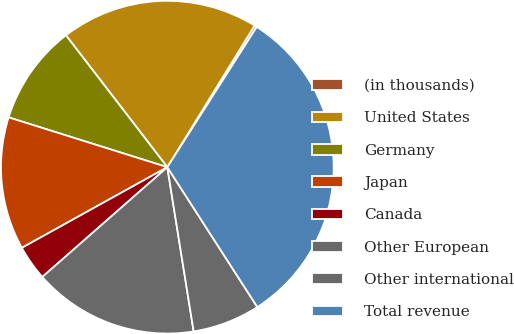<chart> <loc_0><loc_0><loc_500><loc_500><pie_chart><fcel>(in thousands)<fcel>United States<fcel>Germany<fcel>Japan<fcel>Canada<fcel>Other European<fcel>Other international<fcel>Total revenue<nl><fcel>0.24%<fcel>19.22%<fcel>9.73%<fcel>12.9%<fcel>3.41%<fcel>16.06%<fcel>6.57%<fcel>31.87%<nl></chart> 